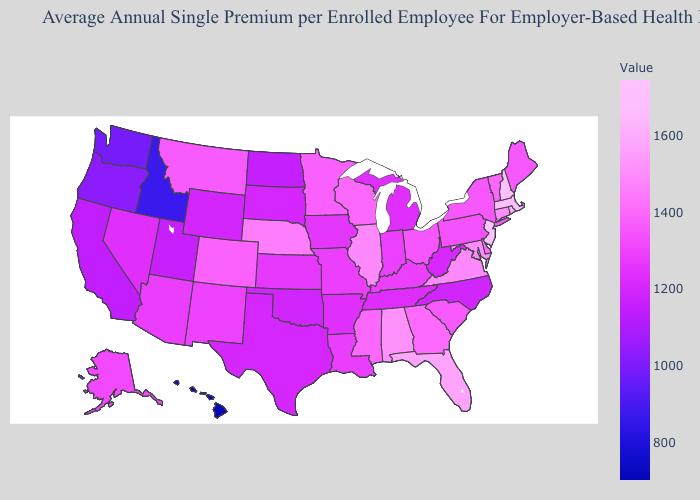Among the states that border South Dakota , does North Dakota have the lowest value?
Answer briefly. Yes. Does Colorado have the highest value in the USA?
Quick response, please. No. Does Colorado have the highest value in the West?
Give a very brief answer. Yes. Which states have the lowest value in the USA?
Answer briefly. Hawaii. Does Massachusetts have the lowest value in the Northeast?
Concise answer only. No. Among the states that border Texas , does Oklahoma have the highest value?
Write a very short answer. No. 